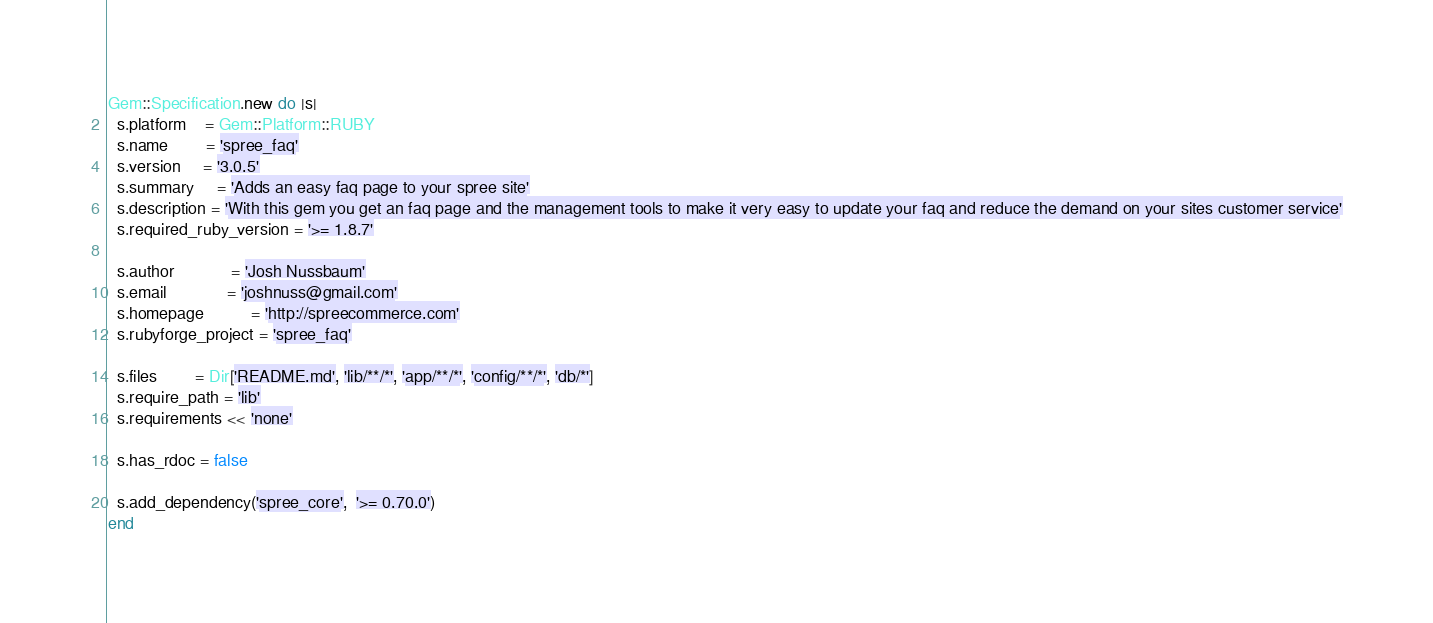Convert code to text. <code><loc_0><loc_0><loc_500><loc_500><_Ruby_>Gem::Specification.new do |s|
  s.platform    = Gem::Platform::RUBY
  s.name        = 'spree_faq'
  s.version     = '3.0.5'
  s.summary     = 'Adds an easy faq page to your spree site'
  s.description = 'With this gem you get an faq page and the management tools to make it very easy to update your faq and reduce the demand on your sites customer service'
  s.required_ruby_version = '>= 1.8.7'

  s.author            = 'Josh Nussbaum'
  s.email             = 'joshnuss@gmail.com'
  s.homepage          = 'http://spreecommerce.com'
  s.rubyforge_project = 'spree_faq'

  s.files        = Dir['README.md', 'lib/**/*', 'app/**/*', 'config/**/*', 'db/*']
  s.require_path = 'lib'
  s.requirements << 'none'

  s.has_rdoc = false

  s.add_dependency('spree_core',  '>= 0.70.0')
end

</code> 